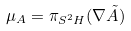<formula> <loc_0><loc_0><loc_500><loc_500>\mu _ { A } = \pi _ { S ^ { 2 } H } ( \nabla \tilde { A } )</formula> 